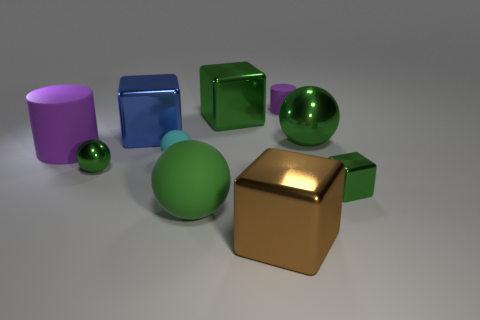How many green spheres must be subtracted to get 1 green spheres? 2 Subtract all red blocks. How many green balls are left? 3 Subtract 1 blocks. How many blocks are left? 3 Subtract all gray cubes. Subtract all brown cylinders. How many cubes are left? 4 Subtract all blocks. How many objects are left? 6 Subtract 0 cyan cylinders. How many objects are left? 10 Subtract all big shiny spheres. Subtract all tiny matte spheres. How many objects are left? 8 Add 5 tiny green metallic things. How many tiny green metallic things are left? 7 Add 7 brown cylinders. How many brown cylinders exist? 7 